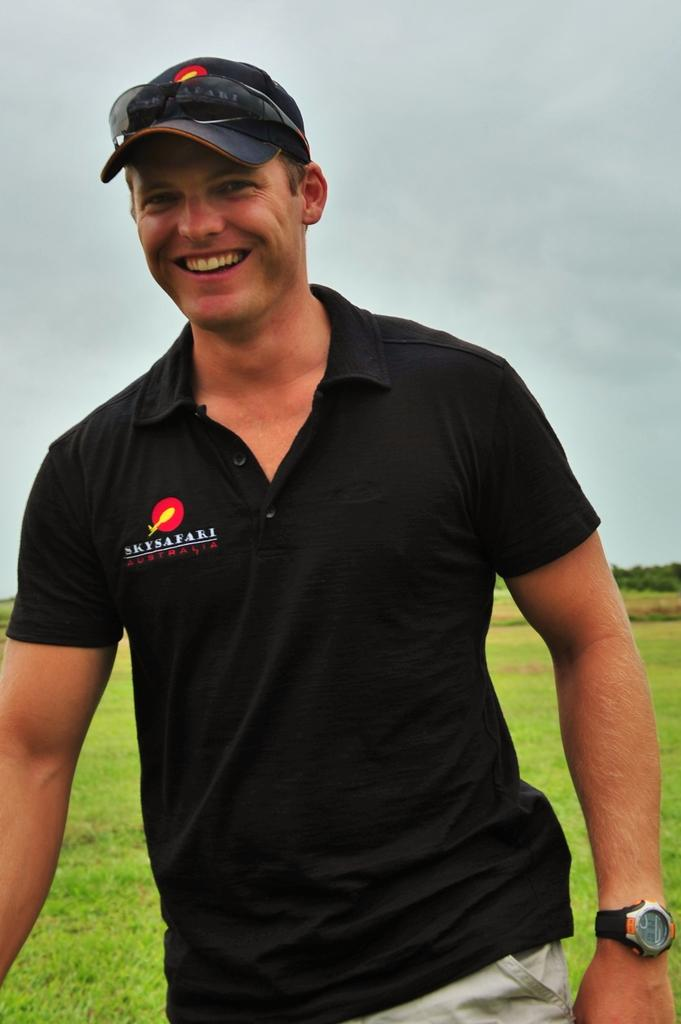What is the main subject of the picture? The main subject of the picture is a man. What is the man doing in the image? The man is standing in the image. What is the man's facial expression? The man is smiling in the image. What accessories is the man wearing? The man is wearing a cap and a watch in the image. What color is the man's shirt? The man's shirt is black in color. What can be seen in the background of the image? There is grass, trees, and the sky visible in the background of the image. What direction is the man facing in the image? The provided facts do not specify the direction the man is facing in the image. Is there a recess happening in the image? There is no indication of a recess or any school-related activity in the image. 